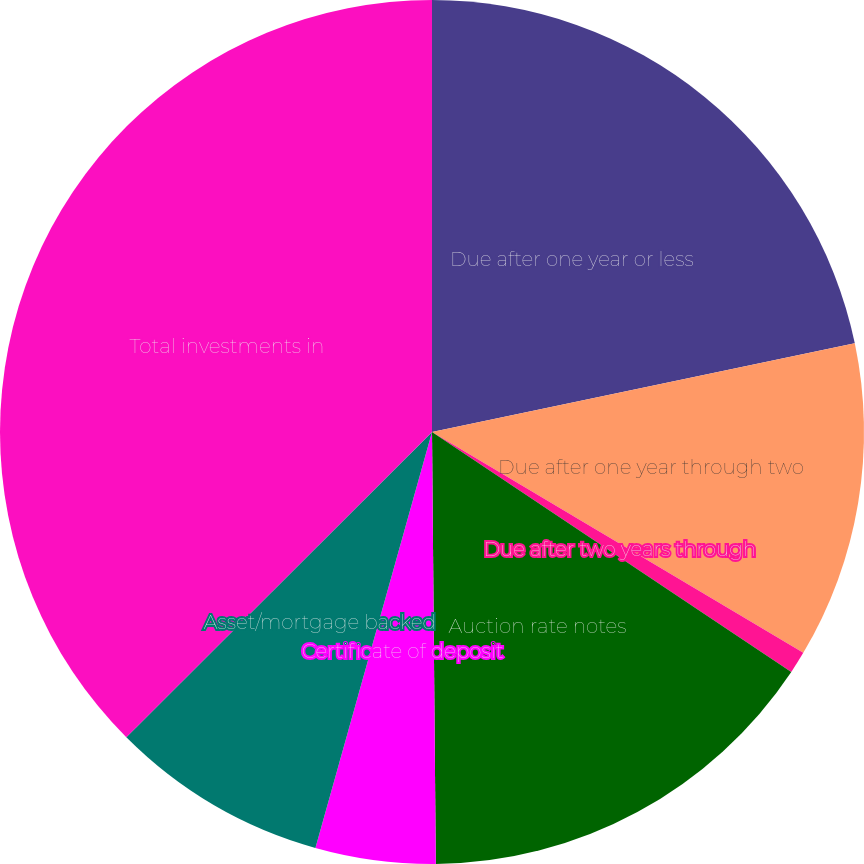Convert chart to OTSL. <chart><loc_0><loc_0><loc_500><loc_500><pie_chart><fcel>Due after one year or less<fcel>Due after one year through two<fcel>Due after two years through<fcel>Auction rate notes<fcel>Certificate of deposit<fcel>Asset/mortgage backed<fcel>Total investments in<nl><fcel>21.71%<fcel>11.83%<fcel>0.83%<fcel>15.49%<fcel>4.49%<fcel>8.16%<fcel>37.49%<nl></chart> 